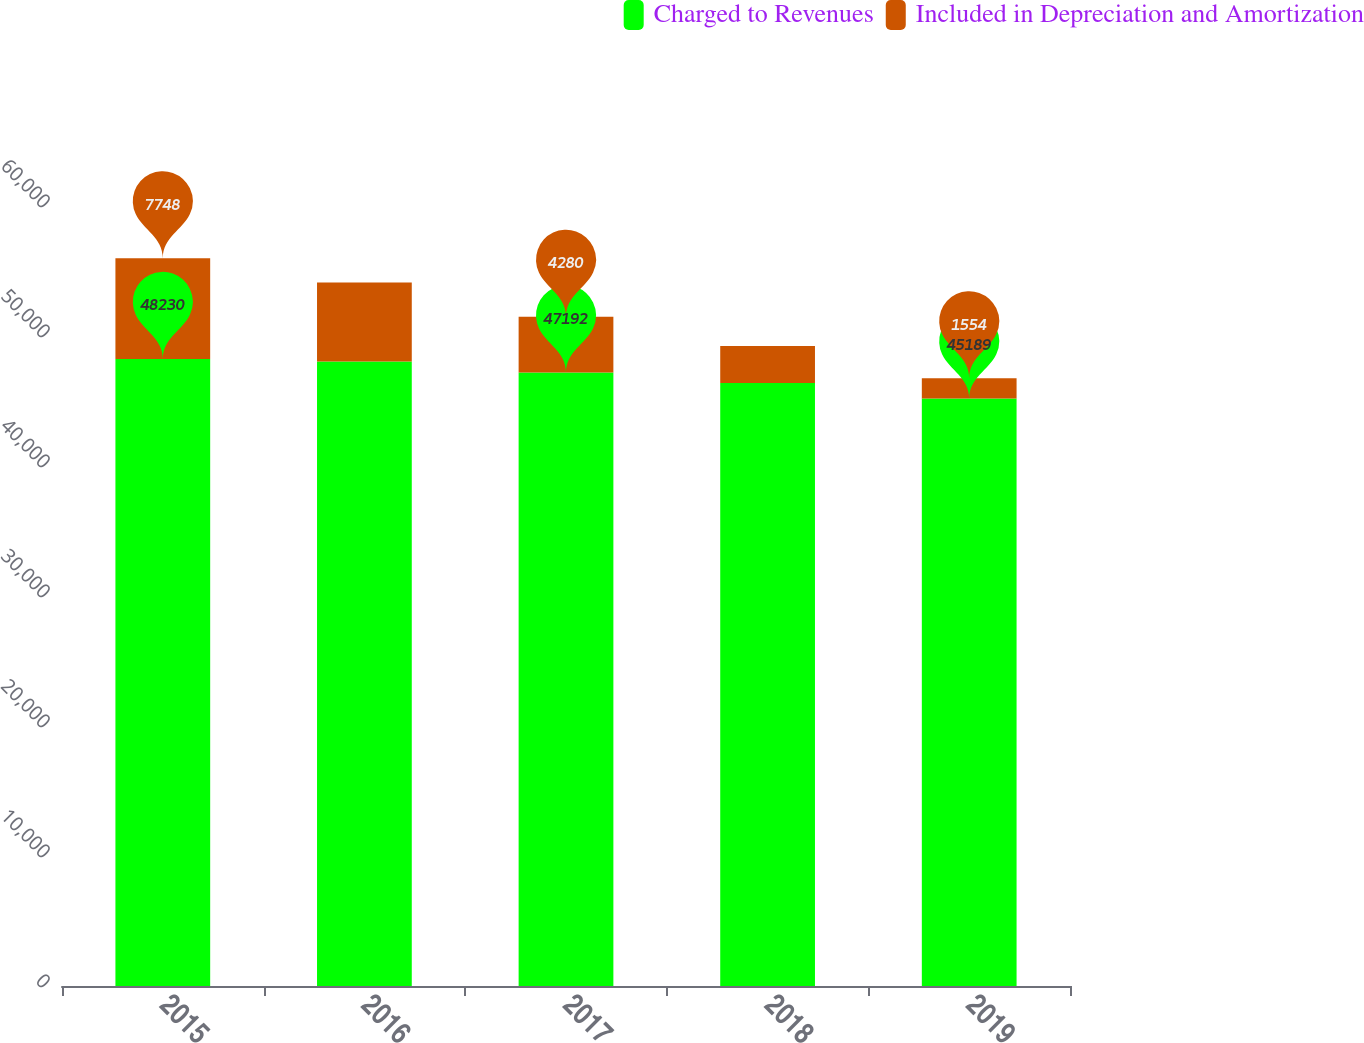Convert chart. <chart><loc_0><loc_0><loc_500><loc_500><stacked_bar_chart><ecel><fcel>2015<fcel>2016<fcel>2017<fcel>2018<fcel>2019<nl><fcel>Charged to Revenues<fcel>48230<fcel>48040<fcel>47192<fcel>46389<fcel>45189<nl><fcel>Included in Depreciation and Amortization<fcel>7748<fcel>6073<fcel>4280<fcel>2838<fcel>1554<nl></chart> 